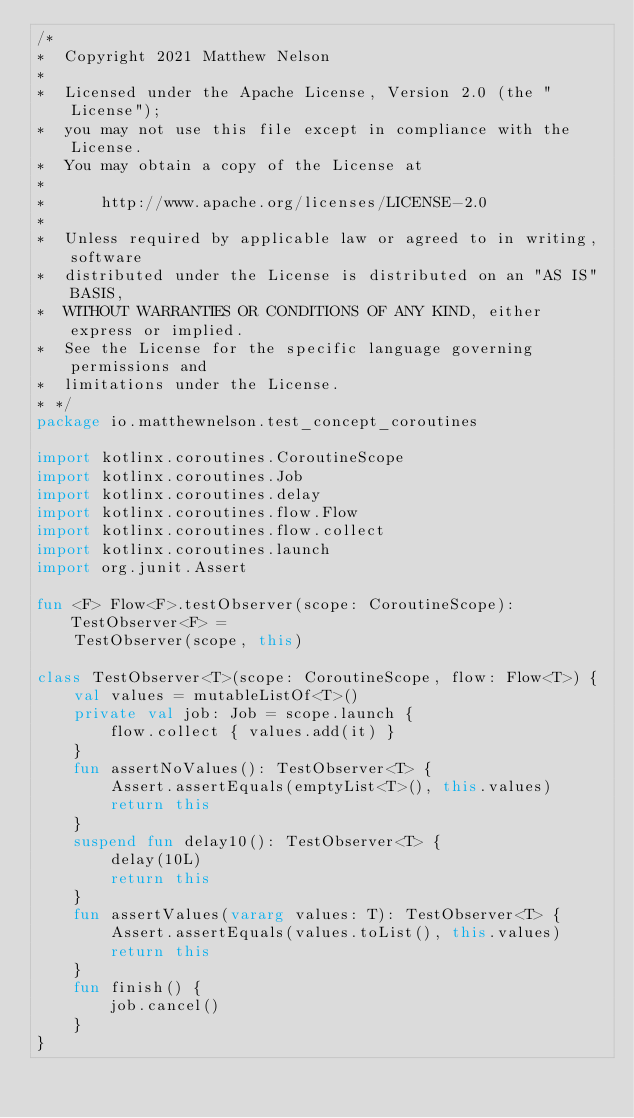<code> <loc_0><loc_0><loc_500><loc_500><_Kotlin_>/*
*  Copyright 2021 Matthew Nelson
*
*  Licensed under the Apache License, Version 2.0 (the "License");
*  you may not use this file except in compliance with the License.
*  You may obtain a copy of the License at
*
*      http://www.apache.org/licenses/LICENSE-2.0
*
*  Unless required by applicable law or agreed to in writing, software
*  distributed under the License is distributed on an "AS IS" BASIS,
*  WITHOUT WARRANTIES OR CONDITIONS OF ANY KIND, either express or implied.
*  See the License for the specific language governing permissions and
*  limitations under the License.
* */
package io.matthewnelson.test_concept_coroutines

import kotlinx.coroutines.CoroutineScope
import kotlinx.coroutines.Job
import kotlinx.coroutines.delay
import kotlinx.coroutines.flow.Flow
import kotlinx.coroutines.flow.collect
import kotlinx.coroutines.launch
import org.junit.Assert

fun <F> Flow<F>.testObserver(scope: CoroutineScope): TestObserver<F> =
    TestObserver(scope, this)

class TestObserver<T>(scope: CoroutineScope, flow: Flow<T>) {
    val values = mutableListOf<T>()
    private val job: Job = scope.launch {
        flow.collect { values.add(it) }
    }
    fun assertNoValues(): TestObserver<T> {
        Assert.assertEquals(emptyList<T>(), this.values)
        return this
    }
    suspend fun delay10(): TestObserver<T> {
        delay(10L)
        return this
    }
    fun assertValues(vararg values: T): TestObserver<T> {
        Assert.assertEquals(values.toList(), this.values)
        return this
    }
    fun finish() {
        job.cancel()
    }
}
</code> 